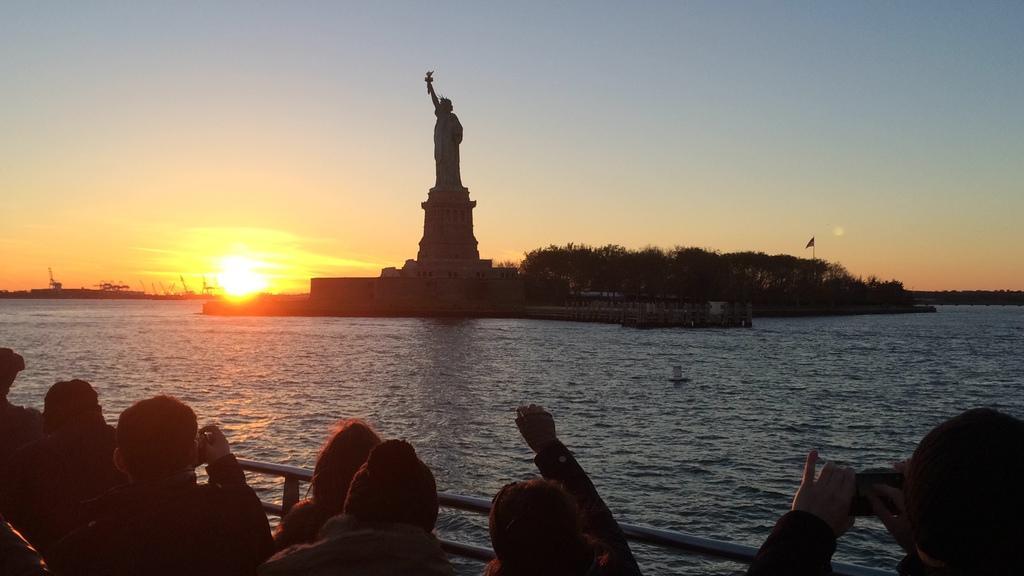Could you give a brief overview of what you see in this image? In this image there is a sea. At the bottom there are a few people looking at the statue, which is placed in the middle of the water and also there are some trees. Some are holding cameras in the hands and taking the pictures of the statue. At the top of the image I can see in the sky along with the sun. 